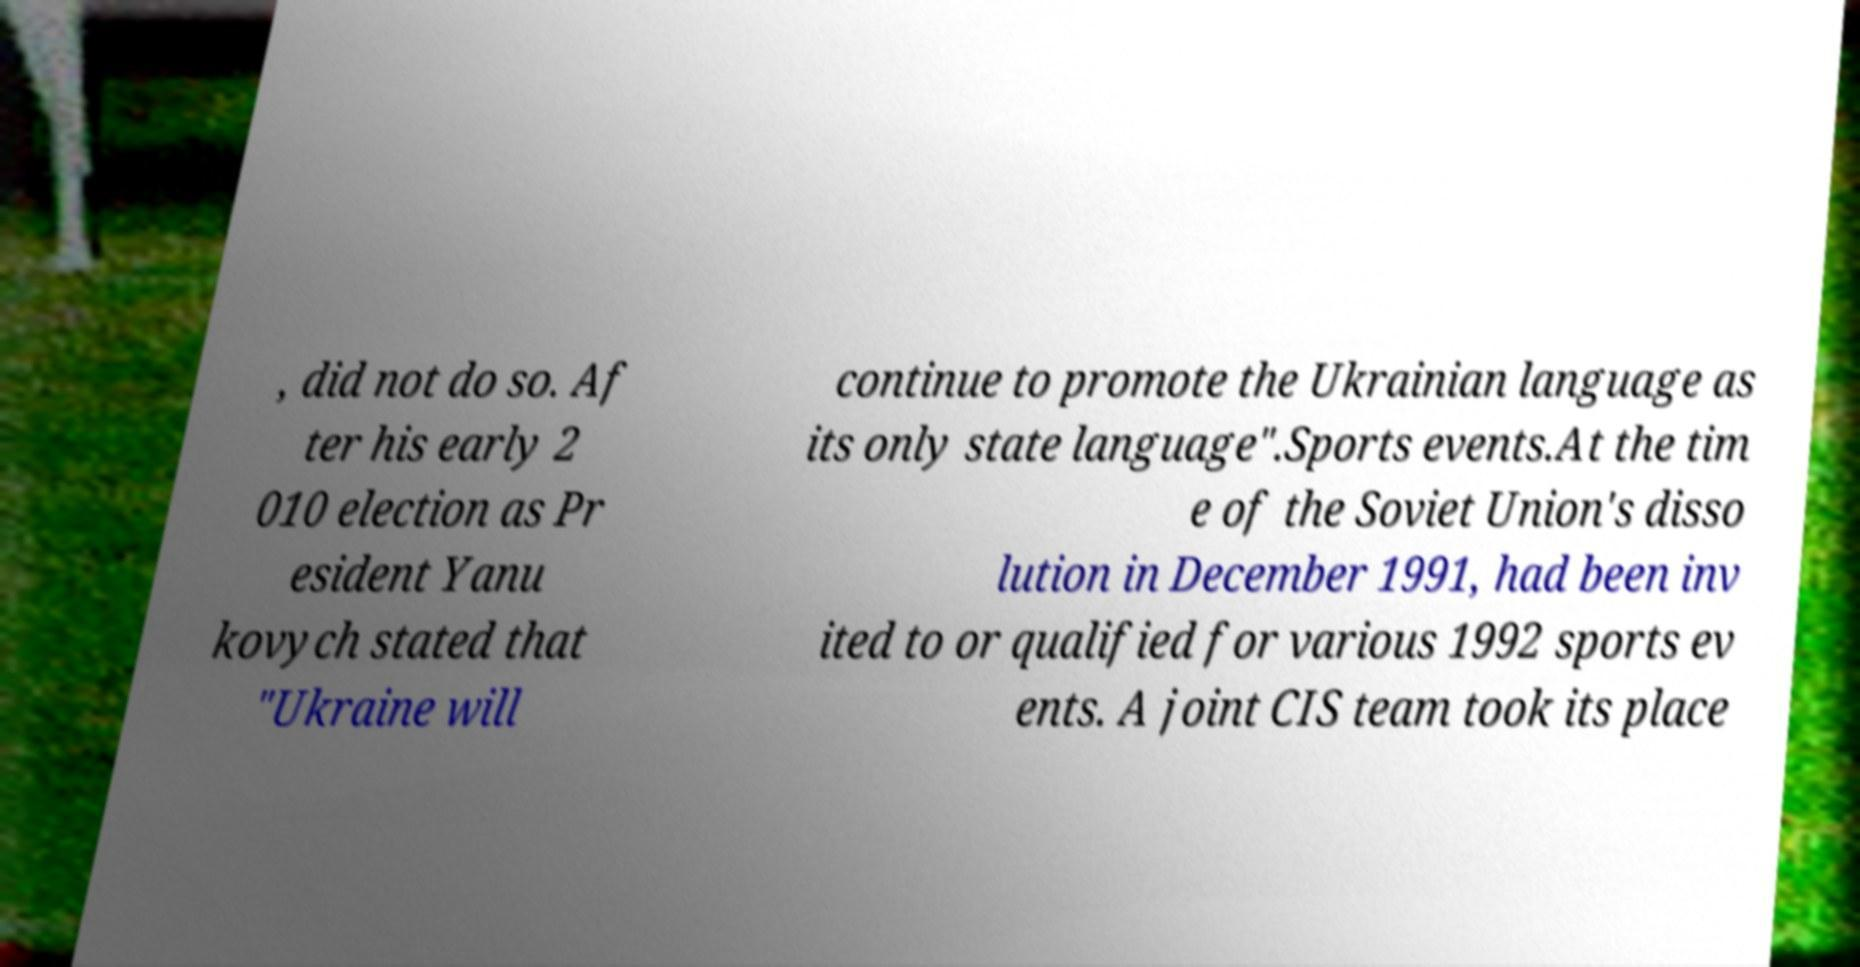What messages or text are displayed in this image? I need them in a readable, typed format. , did not do so. Af ter his early 2 010 election as Pr esident Yanu kovych stated that "Ukraine will continue to promote the Ukrainian language as its only state language".Sports events.At the tim e of the Soviet Union's disso lution in December 1991, had been inv ited to or qualified for various 1992 sports ev ents. A joint CIS team took its place 